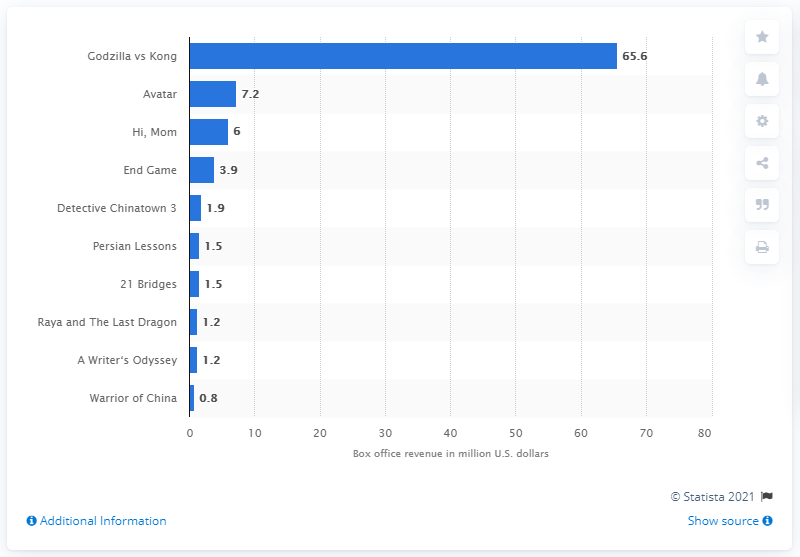Mention a couple of crucial points in this snapshot. Godzilla vs. Kong generated an estimated box office revenue of 65.6 million dollars. Avatar added $7.2 million U.S. dollars to its total box office revenue of $240 million U.S. dollars in China. 